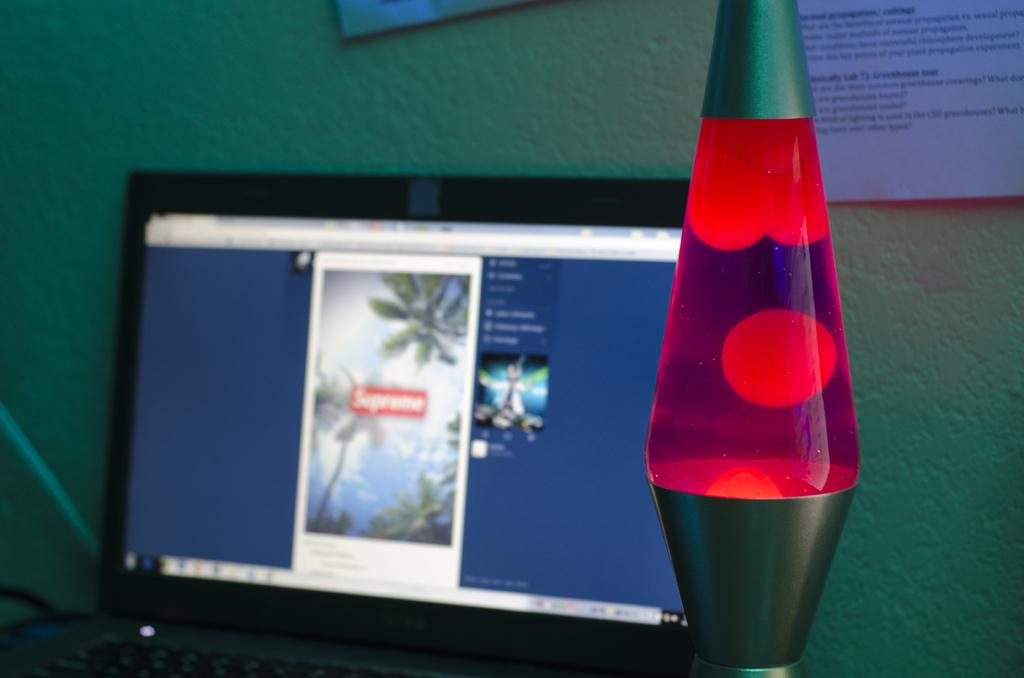<image>
Summarize the visual content of the image. a pink lava lamp in front of a monitor reading SUPREME 